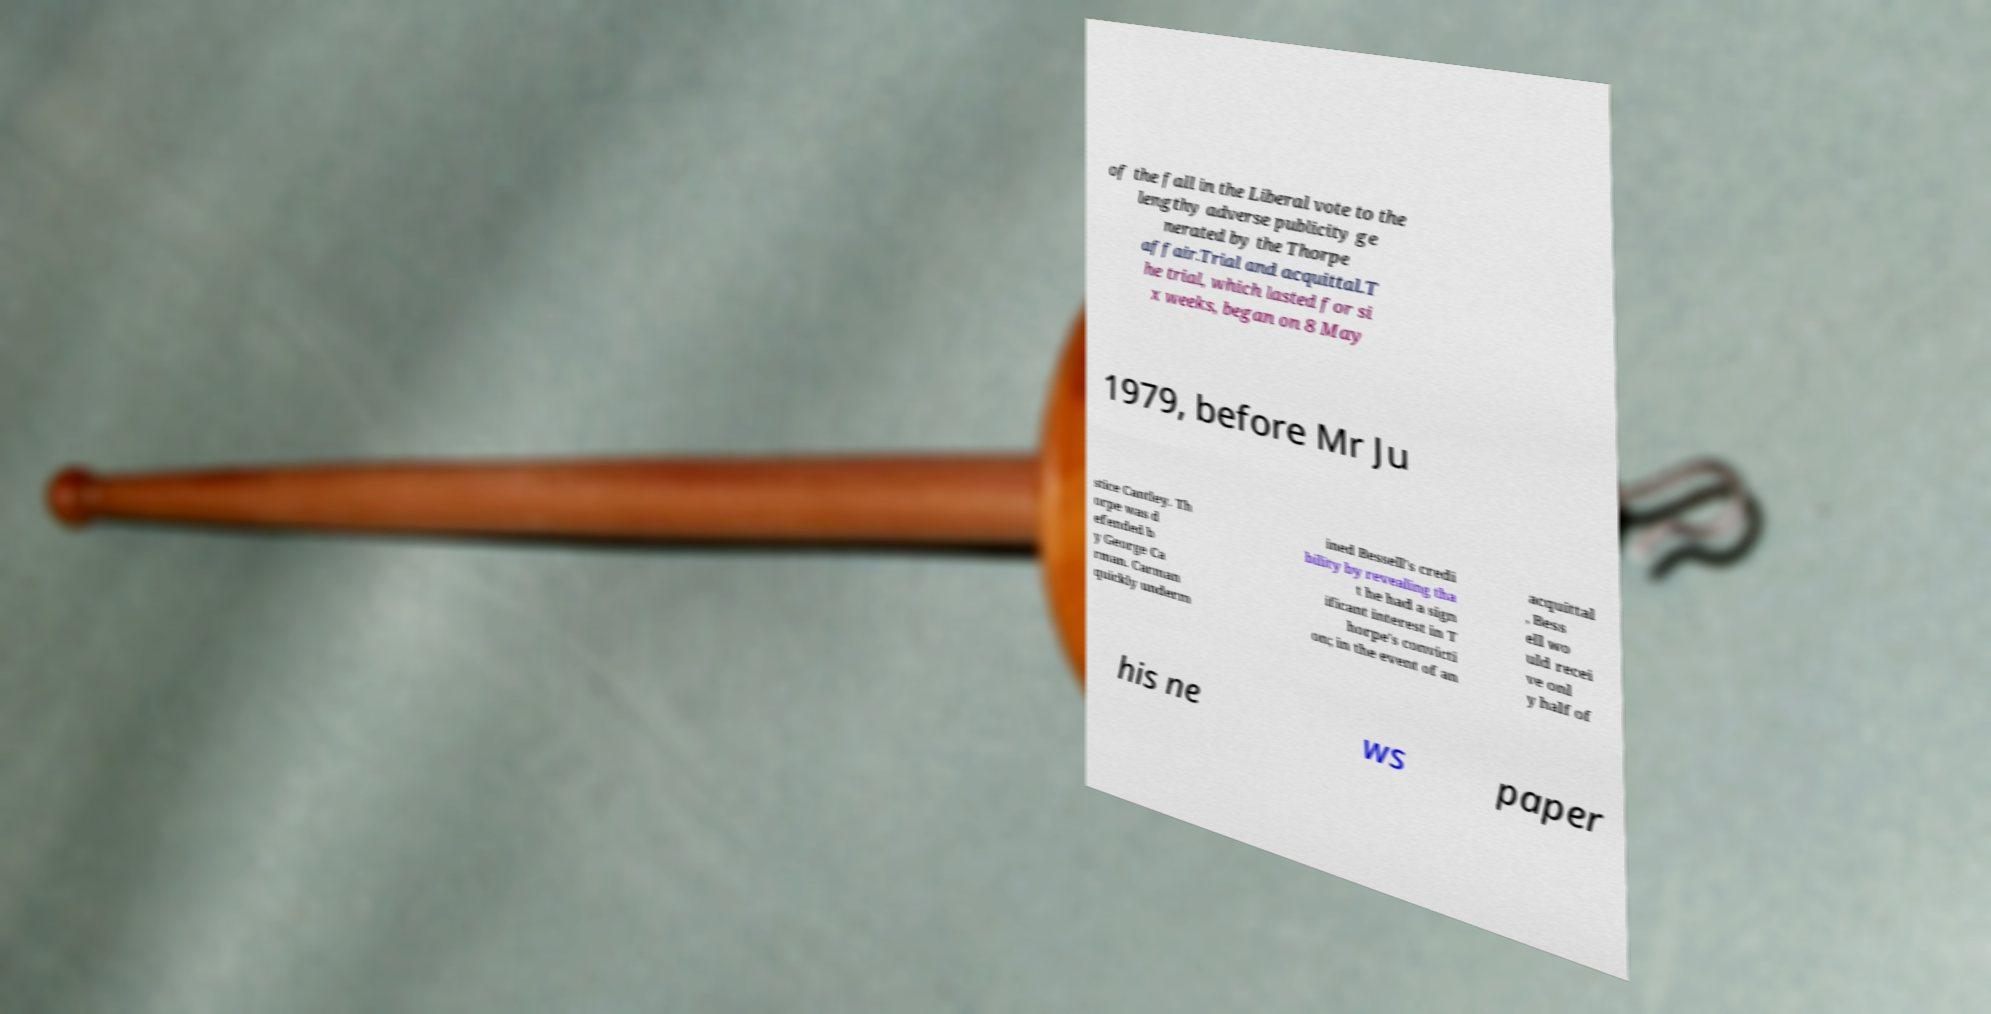Can you accurately transcribe the text from the provided image for me? of the fall in the Liberal vote to the lengthy adverse publicity ge nerated by the Thorpe affair.Trial and acquittal.T he trial, which lasted for si x weeks, began on 8 May 1979, before Mr Ju stice Cantley. Th orpe was d efended b y George Ca rman. Carman quickly underm ined Bessell's credi bility by revealing tha t he had a sign ificant interest in T horpe's convicti on; in the event of an acquittal , Bess ell wo uld recei ve onl y half of his ne ws paper 